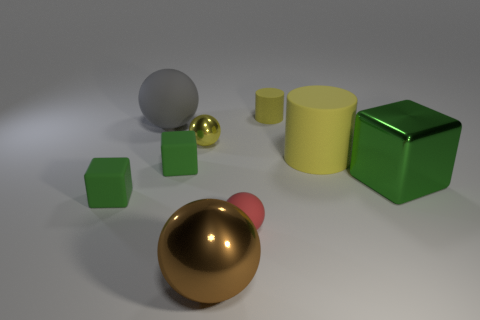How many green blocks must be subtracted to get 1 green blocks? 2 Subtract all red spheres. Subtract all blue blocks. How many spheres are left? 3 Add 1 large things. How many objects exist? 10 Subtract all cylinders. How many objects are left? 7 Subtract 0 gray cylinders. How many objects are left? 9 Subtract all small yellow rubber cylinders. Subtract all shiny blocks. How many objects are left? 7 Add 4 big matte objects. How many big matte objects are left? 6 Add 1 large shiny cubes. How many large shiny cubes exist? 2 